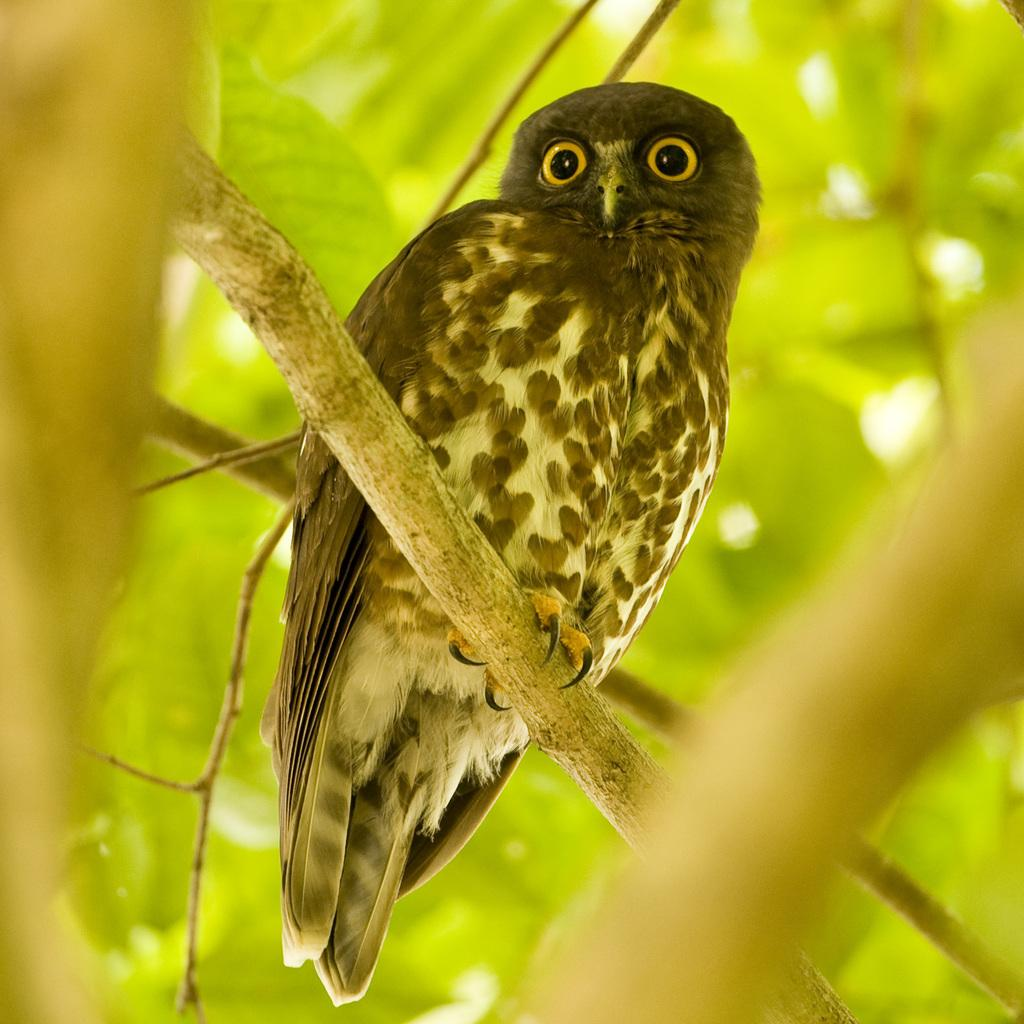What animal is present in the image? There is an owl in the image. Where is the owl located? The owl is on a tree. Can you describe the background of the image? The background of the image is blurry. What type of voyage is the owl embarking on in the image? There is no indication of a voyage in the image; the owl is simply perched on a tree. 